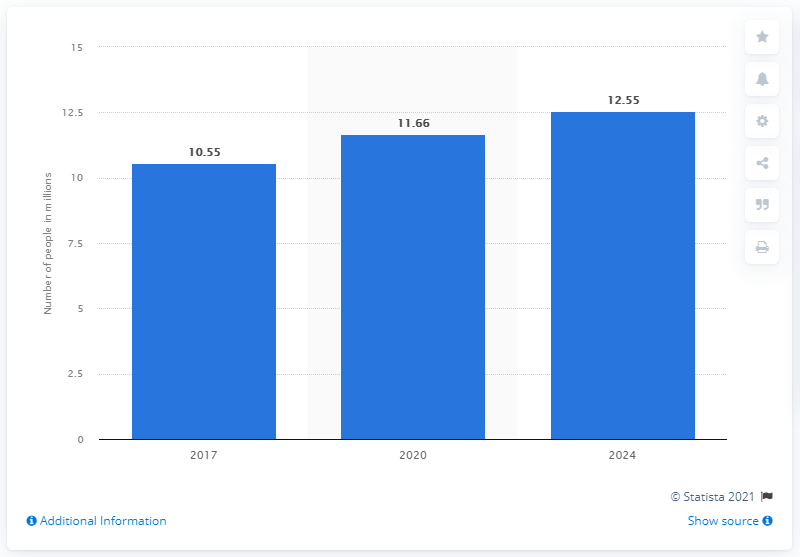List a handful of essential elements in this visual. By 2024, it is projected that there will be approximately 12.55 patients suffering from chronic kidney disease. 